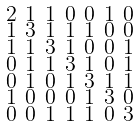<formula> <loc_0><loc_0><loc_500><loc_500>\begin{smallmatrix} 2 & 1 & 1 & 0 & 0 & 1 & 0 \\ 1 & 3 & 1 & 1 & 1 & 0 & 0 \\ 1 & 1 & 3 & 1 & 0 & 0 & 1 \\ 0 & 1 & 1 & 3 & 1 & 0 & 1 \\ 0 & 1 & 0 & 1 & 3 & 1 & 1 \\ 1 & 0 & 0 & 0 & 1 & 3 & 0 \\ 0 & 0 & 1 & 1 & 1 & 0 & 3 \end{smallmatrix}</formula> 